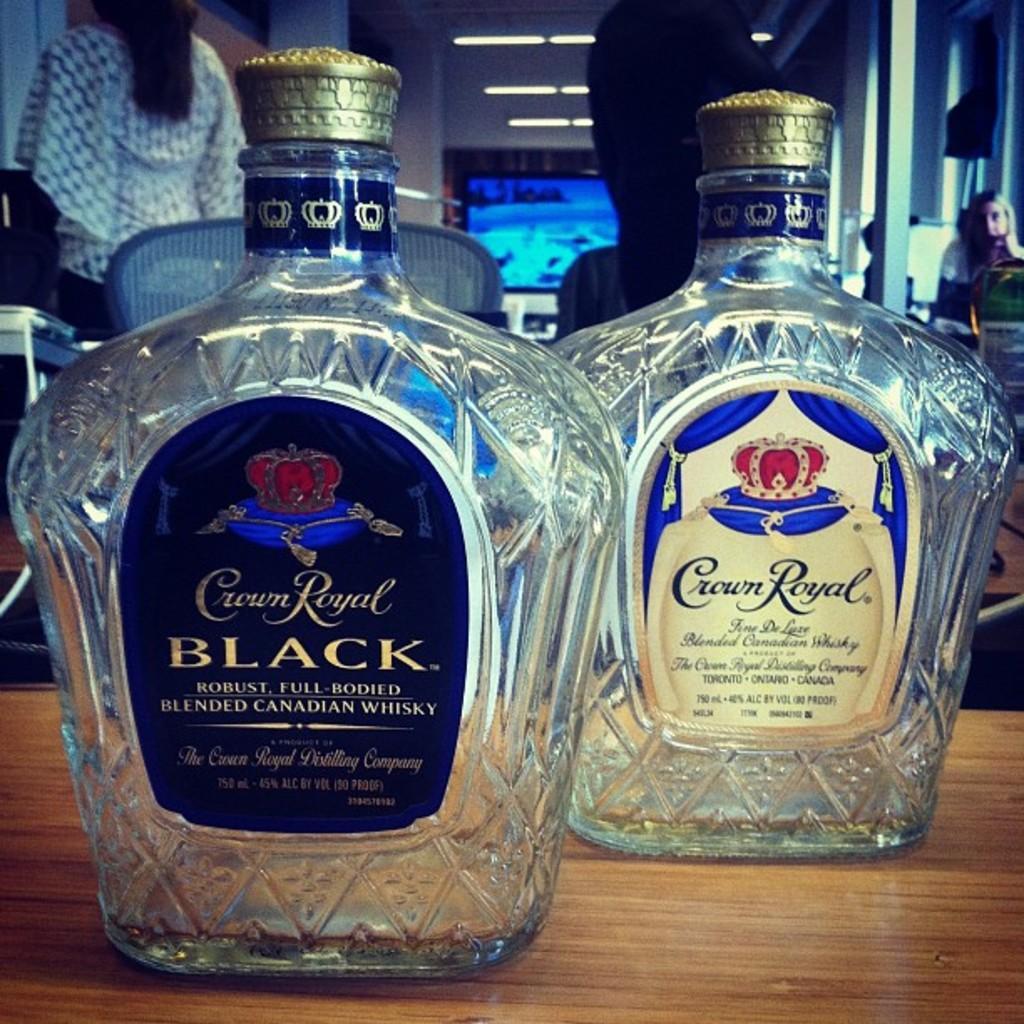Please provide a concise description of this image. There are two empty wine bottles on a table. 